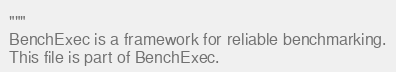Convert code to text. <code><loc_0><loc_0><loc_500><loc_500><_Python_>"""
BenchExec is a framework for reliable benchmarking.
This file is part of BenchExec.
</code> 